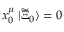<formula> <loc_0><loc_0><loc_500><loc_500>x _ { 0 } ^ { \mu } \, | \widetilde { \Xi } _ { 0 } \rangle = 0 \,</formula> 